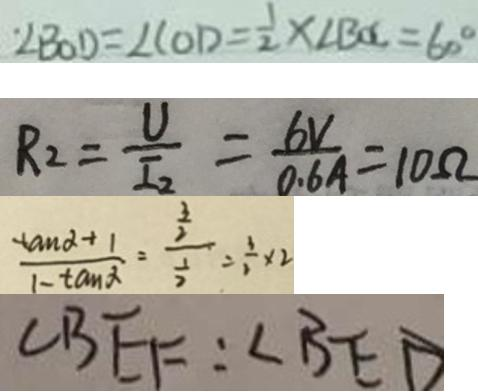Convert formula to latex. <formula><loc_0><loc_0><loc_500><loc_500>\angle B O D = \angle C O D = \frac { 1 } { 2 } \times \angle B O C = 6 0 ^ { \circ } 
 R _ { 2 } = \frac { U } { I _ { 2 } } = \frac { 6 V } { 0 . 6 A } = 1 0 \Omega 
 \frac { \tan \alpha + 1 } { 1 - \tan \alpha } = \frac { \frac { 3 } { 2 } } { \frac { 1 } { 2 } } = \frac { 3 } { 2 } \times 2 
 \angle B E F : \angle B E D</formula> 